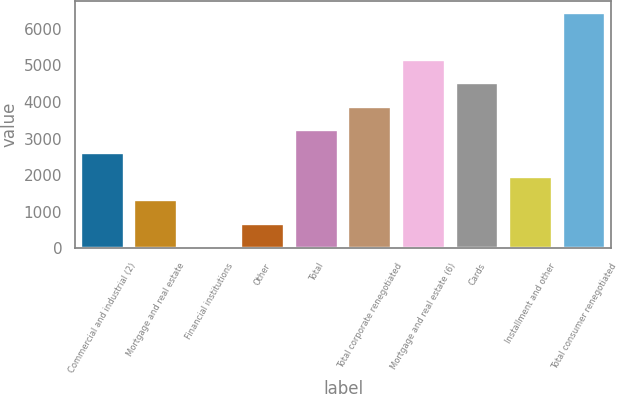<chart> <loc_0><loc_0><loc_500><loc_500><bar_chart><fcel>Commercial and industrial (2)<fcel>Mortgage and real estate<fcel>Financial institutions<fcel>Other<fcel>Total<fcel>Total corporate renegotiated<fcel>Mortgage and real estate (6)<fcel>Cards<fcel>Installment and other<fcel>Total consumer renegotiated<nl><fcel>2594.6<fcel>1313.8<fcel>33<fcel>673.4<fcel>3235<fcel>3875.4<fcel>5156.2<fcel>4515.8<fcel>1954.2<fcel>6437<nl></chart> 